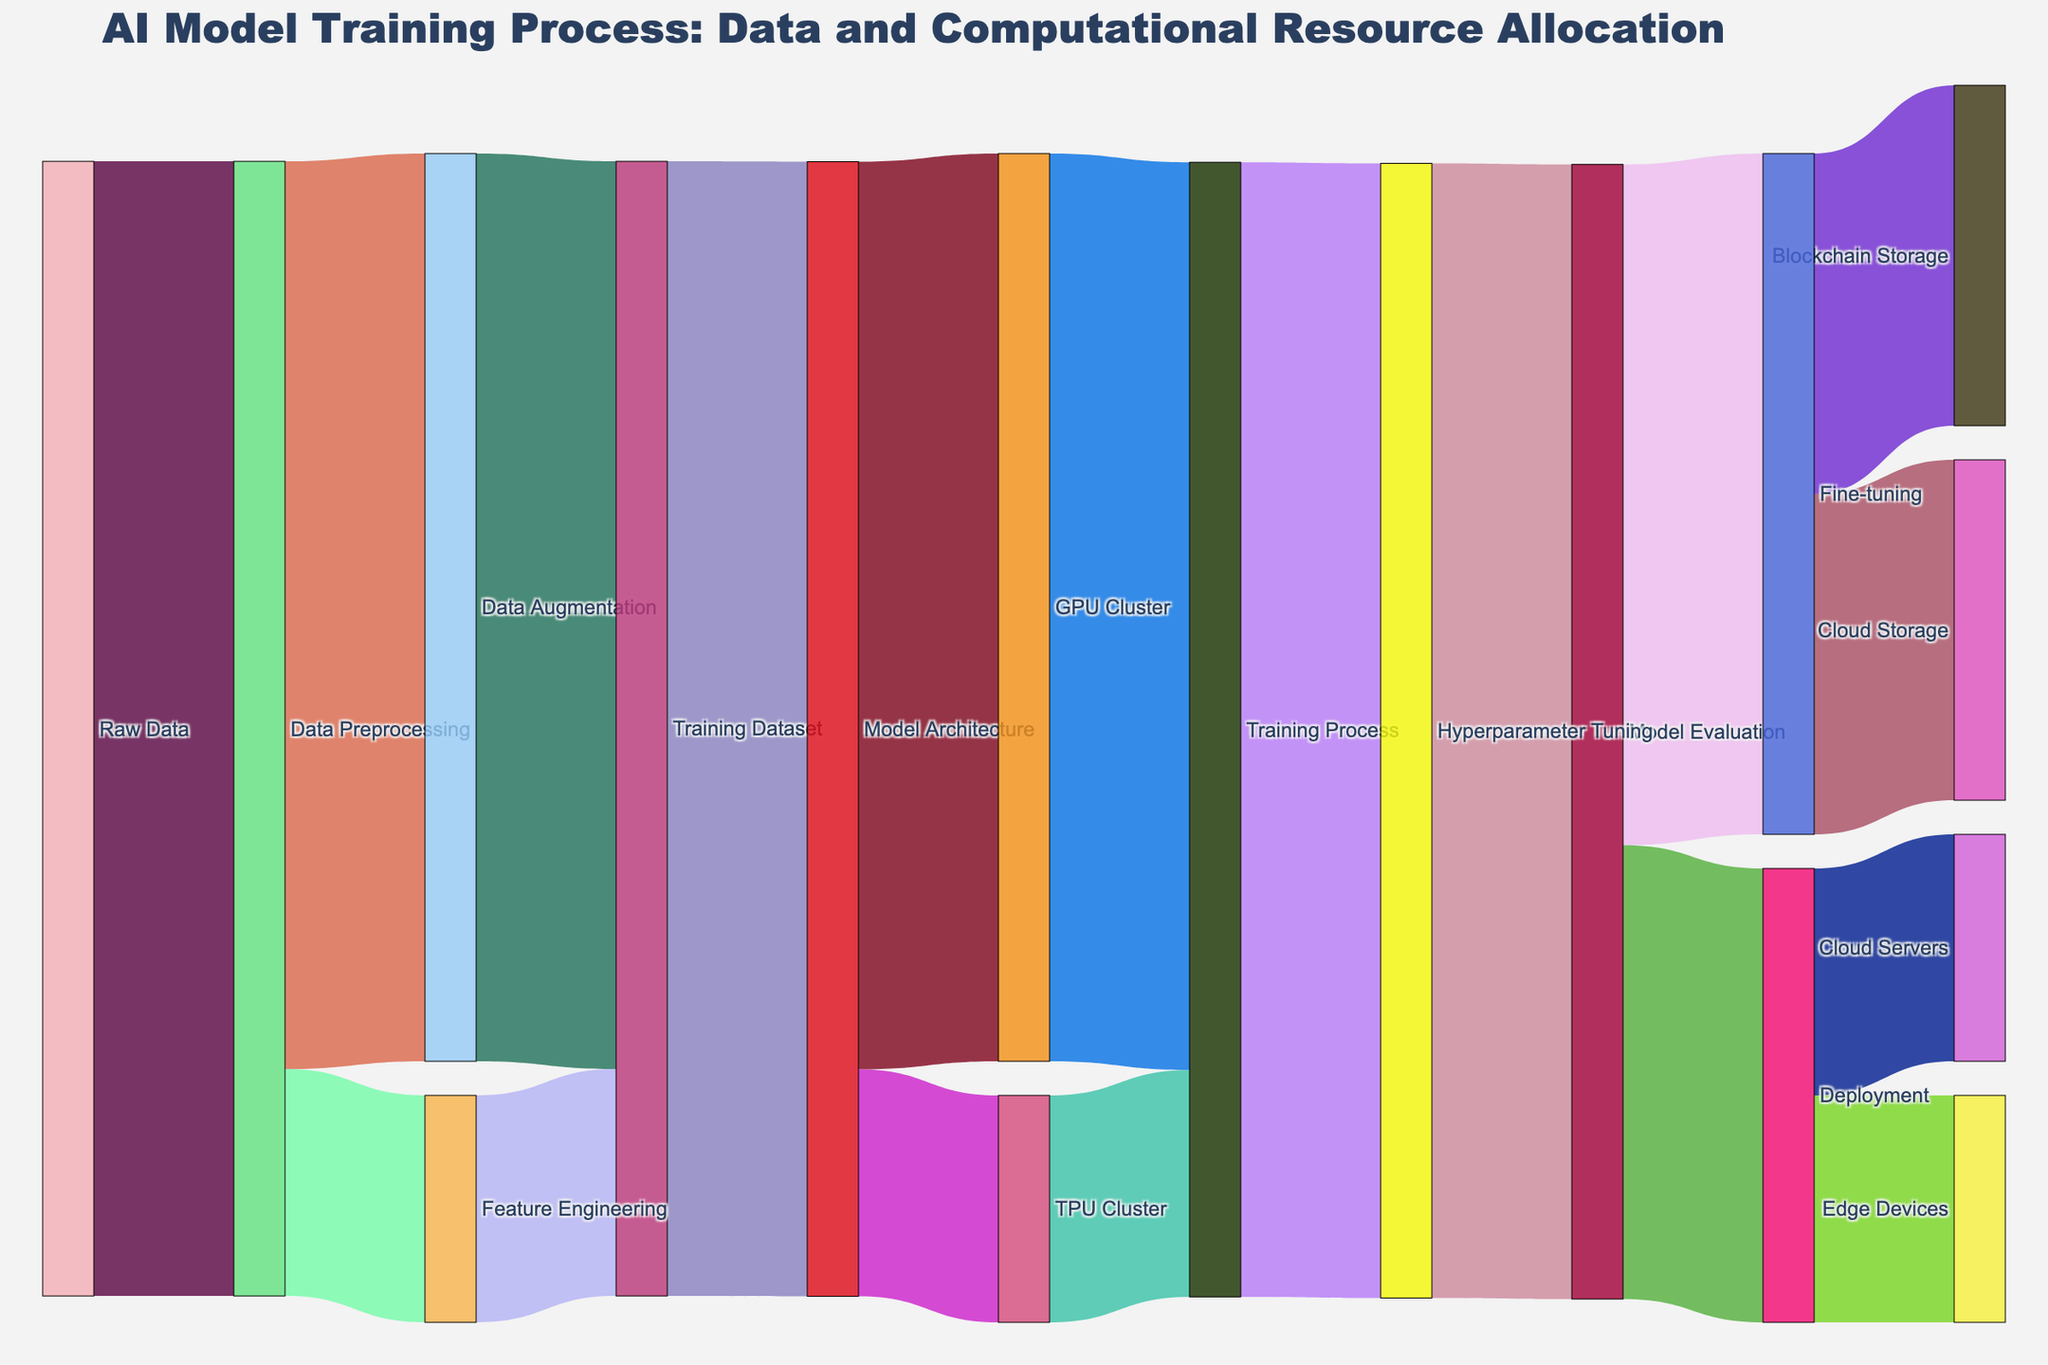What is the title of the Sankey diagram? The title is the main heading at the top of the diagram providing a summary of what the diagram represents. It is placed prominently and typically is larger in font size compared to other text.
Answer: AI Model Training Process: Data and Computational Resource Allocation Which stage receives the most data from "Data Preprocessing"? To determine this, one needs to look at the connections flowing from "Data Preprocessing" and compare the values. "Data Augmentation" receives 800, while "Feature Engineering" receives 200.
Answer: Data Augmentation What is the total amount of resources used in the "Training Process"? To find this, sum the values coming into the "Training Process" stage. It receives 800 from "GPU Cluster" and 200 from "TPU Cluster," resulting in a total of 1000.
Answer: 1000 How much data is successfully deployed to "Edge Devices"? Follow the connections from "Deployment" and check the value flowing into "Edge Devices."
Answer: 200 Which stage processes more data: "GPU Cluster" or "TPU Cluster"? Check the values associated with each stage. The "GPU Cluster" processes 800, while the "TPU Cluster" processes 200.
Answer: GPU Cluster What is the difference in data allocation between "Hyperparameter Tuning" and "Model Evaluation"? "Hyperparameter Tuning" receives 1000 while "Model Evaluation" also receives 1000, hence the difference is 0.
Answer: 0 Which stages are directly involved in storing the fine-tuned model? Trace the connections from "Fine-tuning" to identify stages involved in storage. These connections lead to "Blockchain Storage" (300) and "Cloud Storage" (300).
Answer: Blockchain Storage and Cloud Storage What is the total data flow going into the "Model Evaluation" stage? Sum the connections going into "Model Evaluation." It receives 1000 from "Hyperparameter Tuning."
Answer: 1000 How does the data allocation compare between "Feature Engineering" and "Training Dataset"? The values indicate that "Feature Engineering" is allocated 200, while the "Training Dataset" receives 1000 (800 from "Data Augmentation" and 200 from "Feature Engineering").
Answer: Training Dataset has more What is the final destination for the data flowing through "Deployment"? Follow the connections from "Deployment" to determine the endpoints. The data ends up in "Edge Devices" (200) and "Cloud Servers" (200).
Answer: Edge Devices and Cloud Servers 